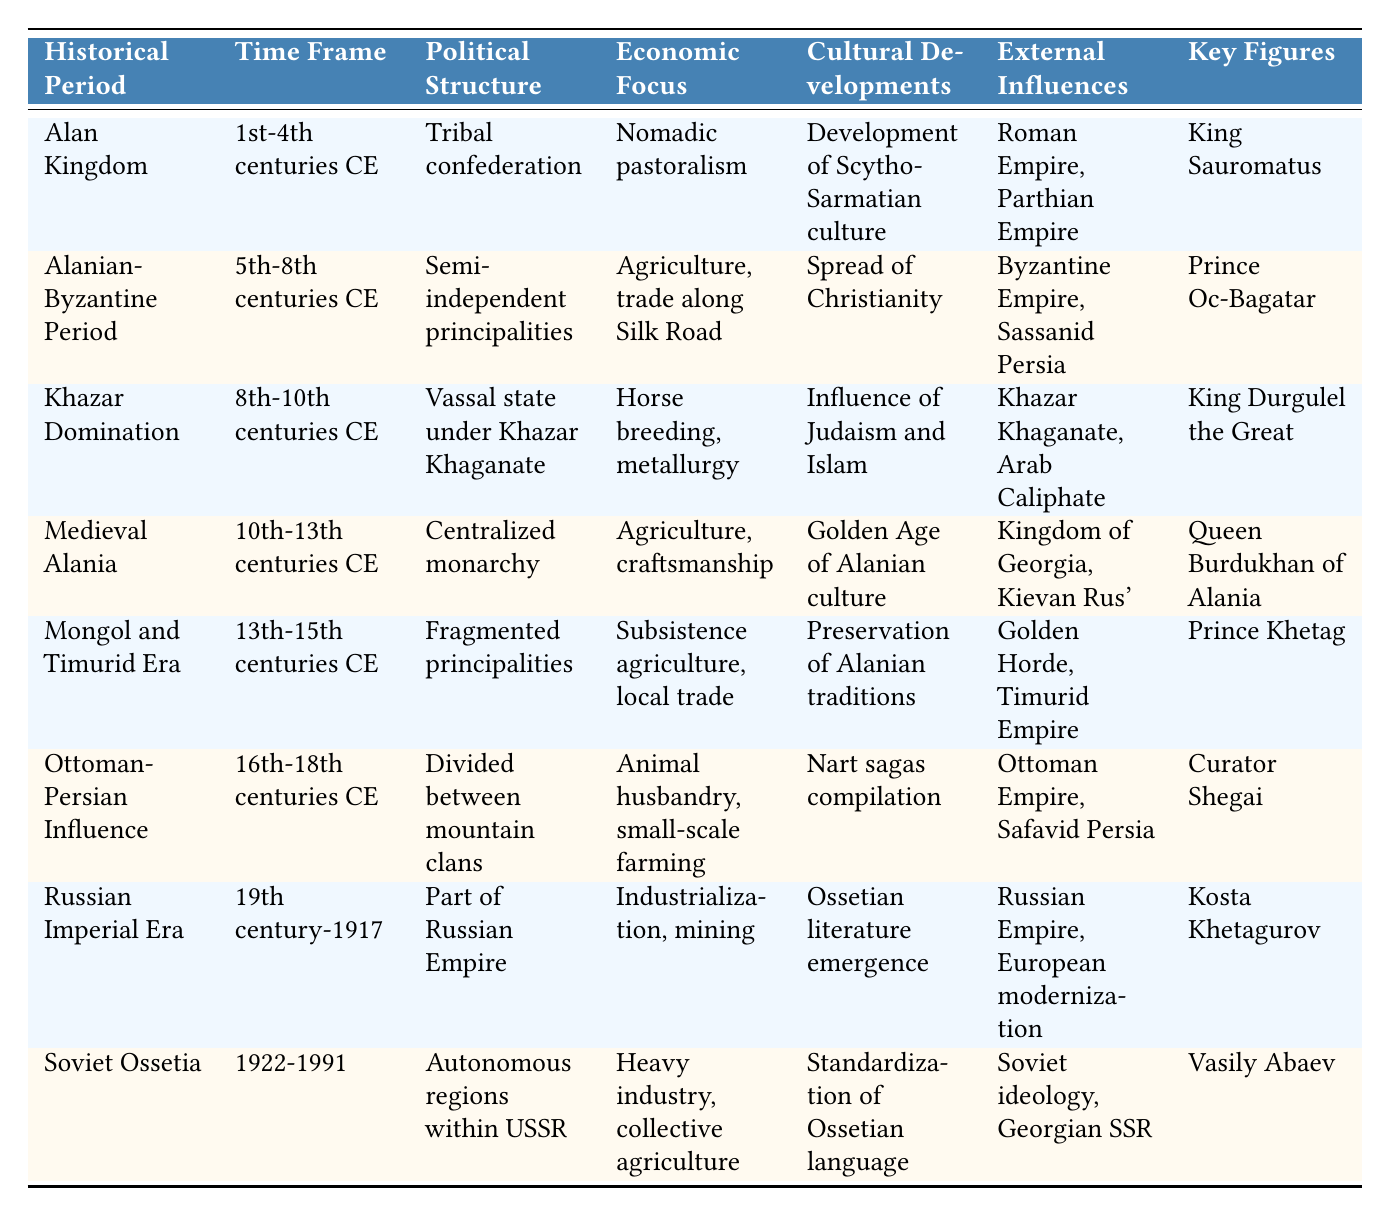What is the time frame of the Alan Kingdom? The table lists the time frame for the Alan Kingdom in the second column, which states "1st-4th centuries CE."
Answer: 1st-4th centuries CE Which historical period is associated with the significant influence of the Byzantine Empire? The table shows that the Alanian-Byzantine Period is the one listed with external influences from the Byzantine Empire, occurring in the 5th-8th centuries CE.
Answer: Alanian-Byzantine Period How many historical periods mentioned focus primarily on subsistence agriculture? To answer, we look for periods where the economic focus is on subsistence agriculture. The table lists "Mongol and Timurid Era" with a focus on "subsistence agriculture, local trade," and "Soviet Ossetia" with "heavy industry, collective agriculture," however, "collective agriculture" is not the same as subsistence agriculture. Therefore, only one period focuses on it.
Answer: 1 Is King Sauromatus a key figure in the Soviet Ossetia period? According to the table, King Sauromatus is listed under the Alan Kingdom, not the Soviet Ossetia period, which features Vasily Abaev as its key figure.
Answer: No What was the political structure during the 10th-13th centuries CE? The appropriate row for the 10th-13th centuries CE is "Medieval Alania," which describes the political structure as a "Centralized monarchy" in the third column.
Answer: Centralized monarchy Which key figure is associated with the Mongol and Timurid Era? By reviewing the table, the key figure identified for the Mongol and Timurid Era is "Prince Khetag," found in the last column of that row.
Answer: Prince Khetag During which historical period did the compilation of Nart sagas occur? Referring to the table, the entry under the 16th-18th centuries CE indicates that "Nart sagas compilation" occurred during the "Ottoman-Persian Influence."
Answer: Ottoman-Persian Influence Among the periods listed, which one had a political structure of a vassal state? The table indicates that the "Khazar Domination," occurring in the 8th-10th centuries CE, describes its political structure as a "Vassal state under Khazar Khaganate."
Answer: Khazar Domination What was the economic focus of the Alanian-Byzantine Period? In the table, the economic focus for the Alanian-Byzantine Period is specified in the fourth column as "Agriculture, trade along Silk Road."
Answer: Agriculture, trade along Silk Road 